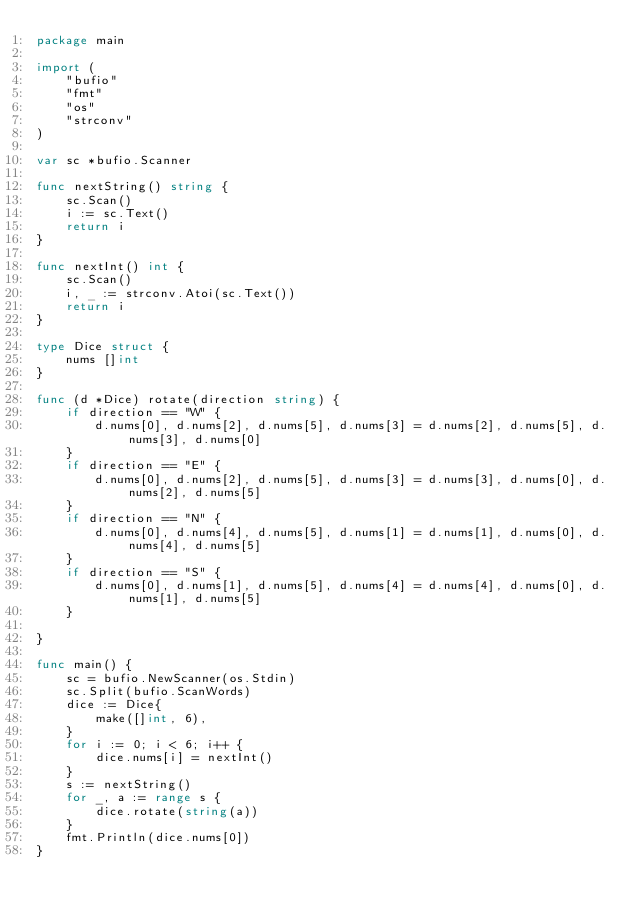Convert code to text. <code><loc_0><loc_0><loc_500><loc_500><_Go_>package main

import (
	"bufio"
	"fmt"
	"os"
	"strconv"
)

var sc *bufio.Scanner

func nextString() string {
	sc.Scan()
	i := sc.Text()
	return i
}

func nextInt() int {
	sc.Scan()
	i, _ := strconv.Atoi(sc.Text())
	return i
}

type Dice struct {
	nums []int
}

func (d *Dice) rotate(direction string) {
	if direction == "W" {
		d.nums[0], d.nums[2], d.nums[5], d.nums[3] = d.nums[2], d.nums[5], d.nums[3], d.nums[0]
	}
	if direction == "E" {
		d.nums[0], d.nums[2], d.nums[5], d.nums[3] = d.nums[3], d.nums[0], d.nums[2], d.nums[5]
	}
	if direction == "N" {
		d.nums[0], d.nums[4], d.nums[5], d.nums[1] = d.nums[1], d.nums[0], d.nums[4], d.nums[5]
	}
	if direction == "S" {
		d.nums[0], d.nums[1], d.nums[5], d.nums[4] = d.nums[4], d.nums[0], d.nums[1], d.nums[5]
	}

}

func main() {
	sc = bufio.NewScanner(os.Stdin)
	sc.Split(bufio.ScanWords)
	dice := Dice{
		make([]int, 6),
	}
	for i := 0; i < 6; i++ {
		dice.nums[i] = nextInt()
	}
	s := nextString()
	for _, a := range s {
		dice.rotate(string(a))
	}
	fmt.Println(dice.nums[0])
}

</code> 